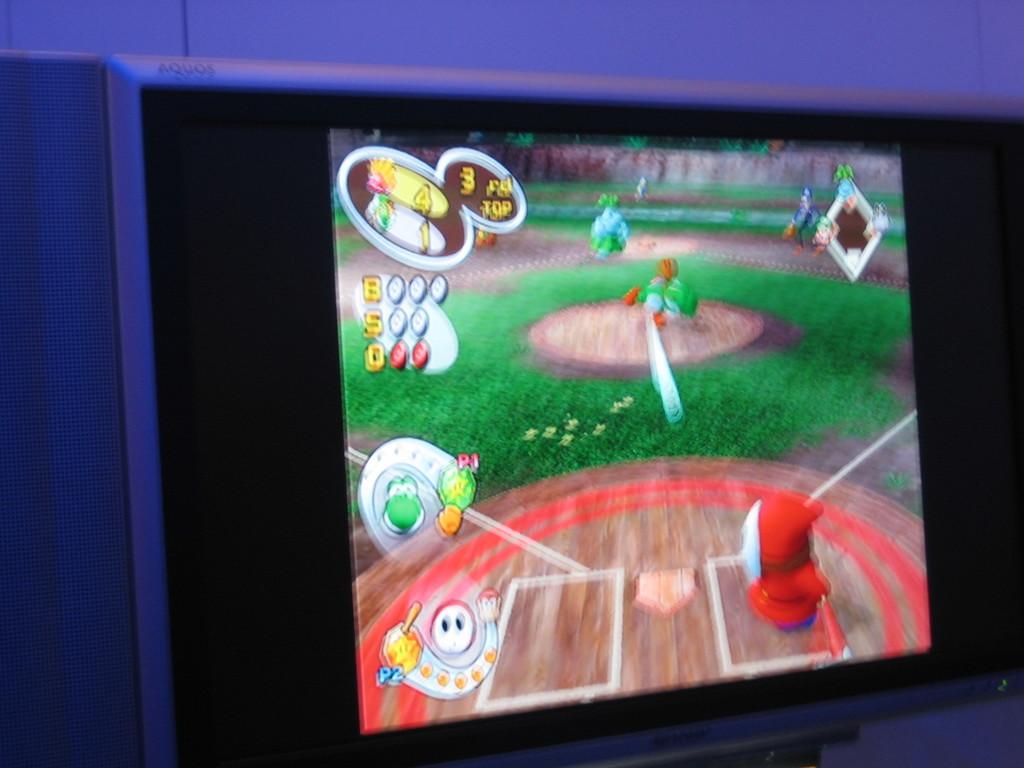What player is shown in the bottom left?
Your response must be concise. Answering does not require reading text in the image. 